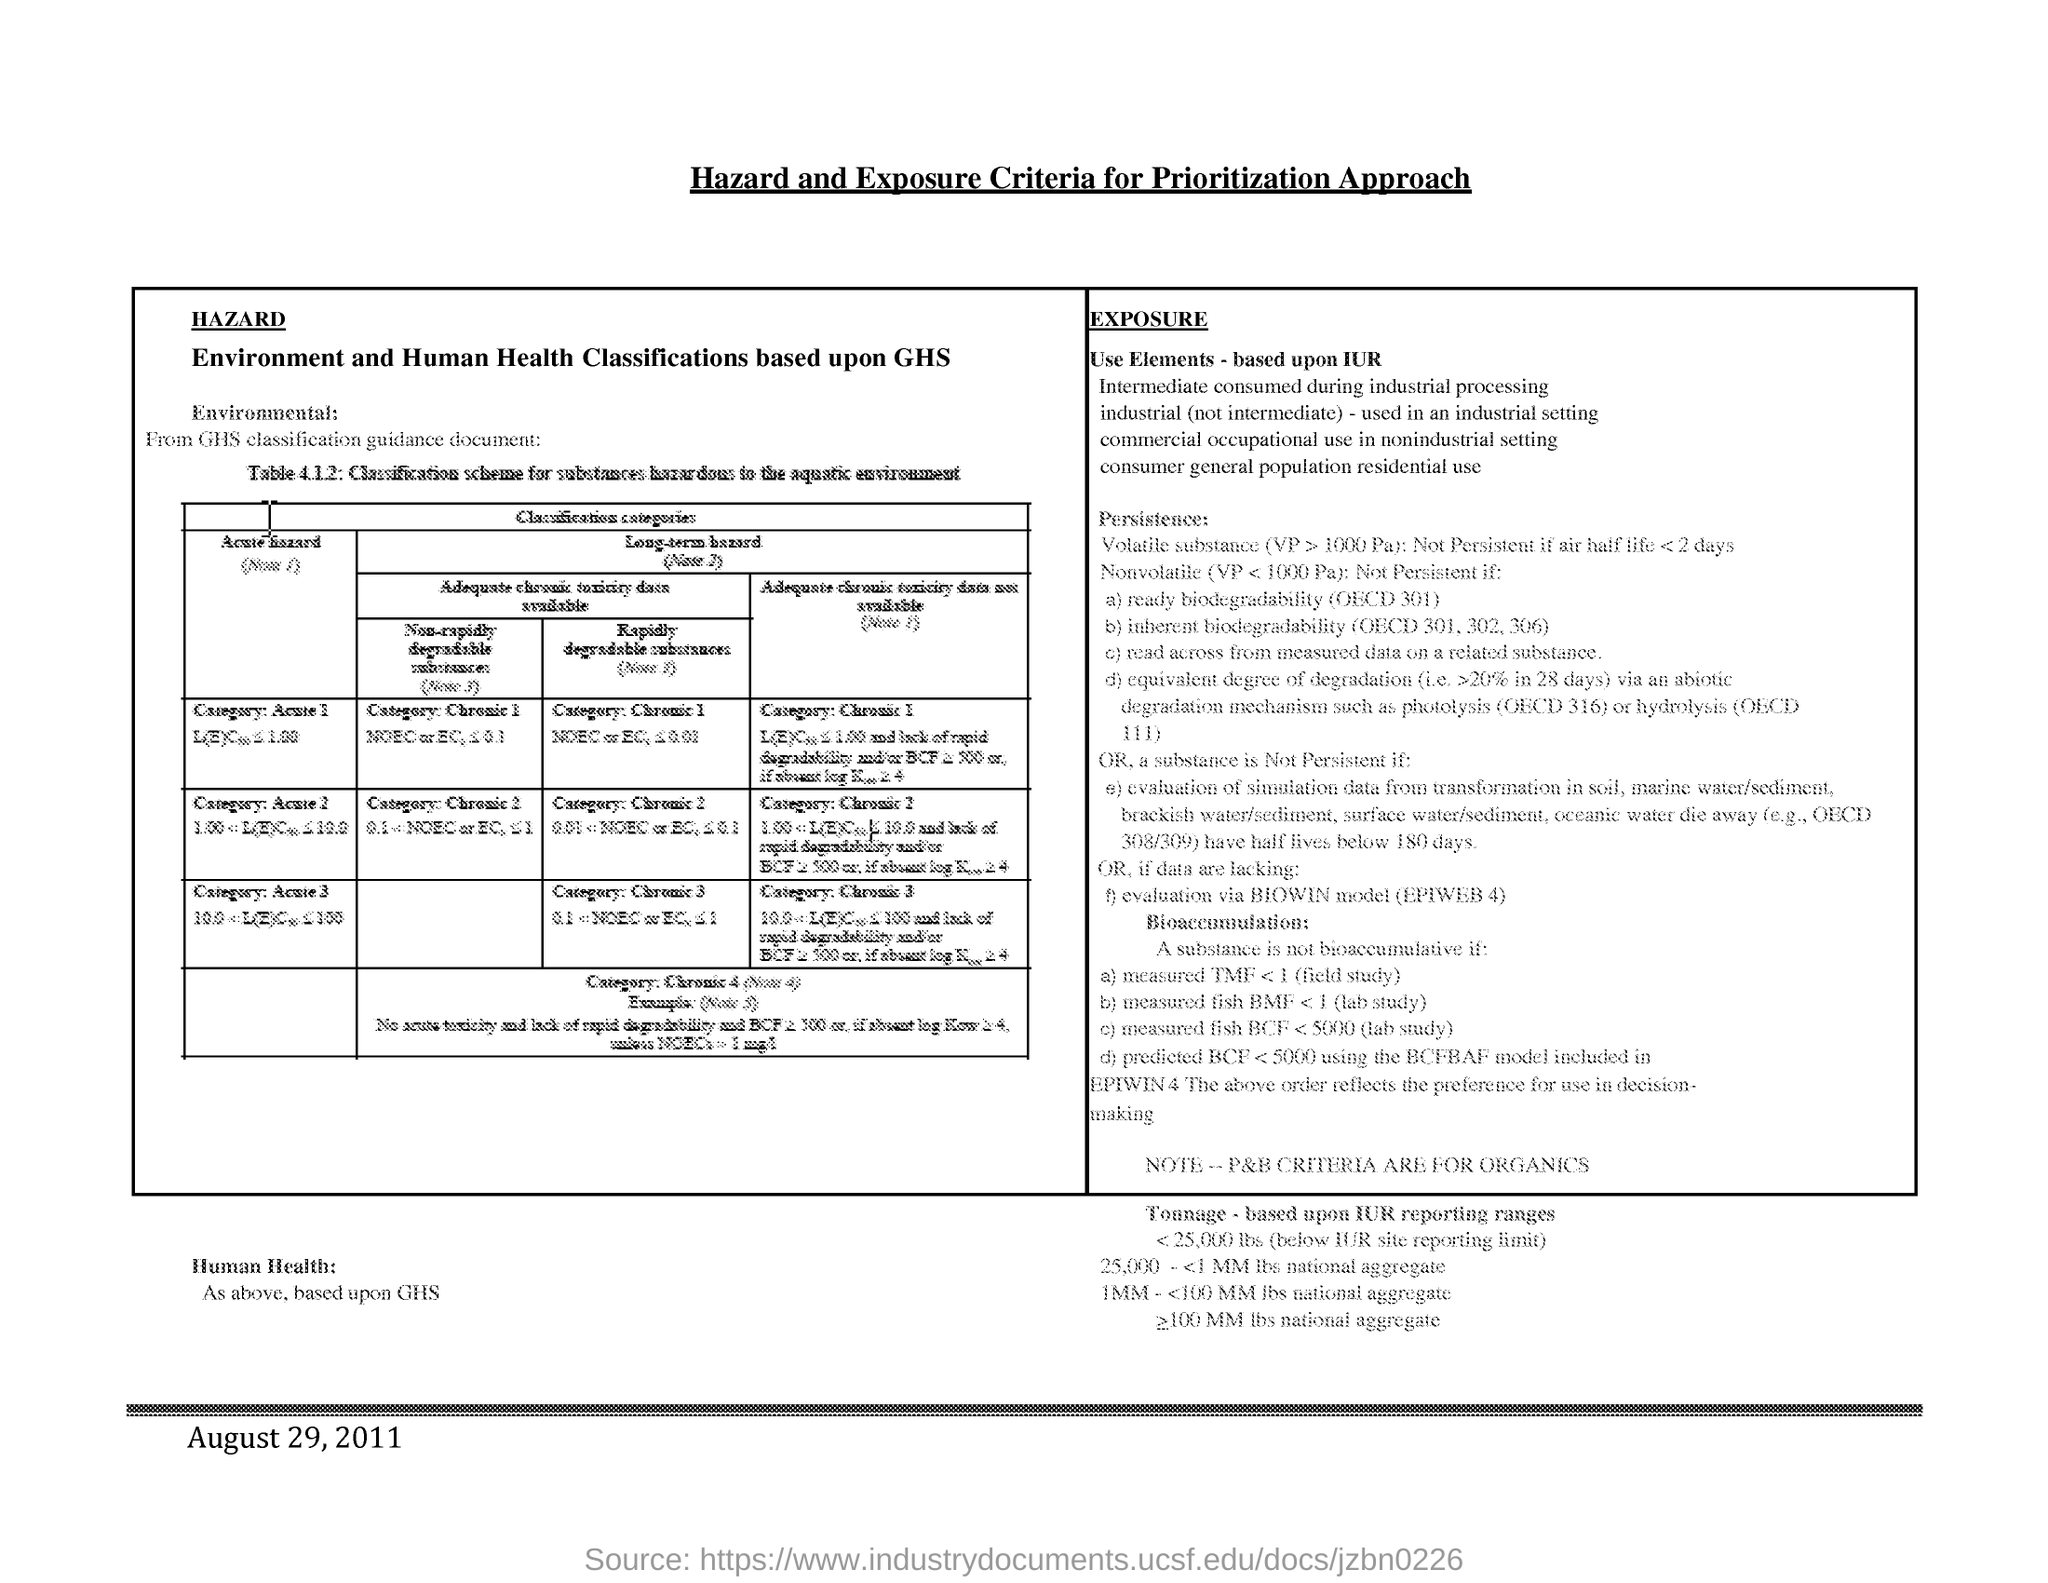Indicate a few pertinent items in this graphic. The document's title is 'Hazard and Exposure Criteria for Prioritization Approach.' The date mentioned in the document is August 29, 2011. 